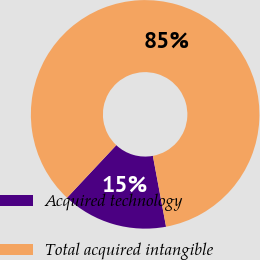<chart> <loc_0><loc_0><loc_500><loc_500><pie_chart><fcel>Acquired technology<fcel>Total acquired intangible<nl><fcel>14.91%<fcel>85.09%<nl></chart> 